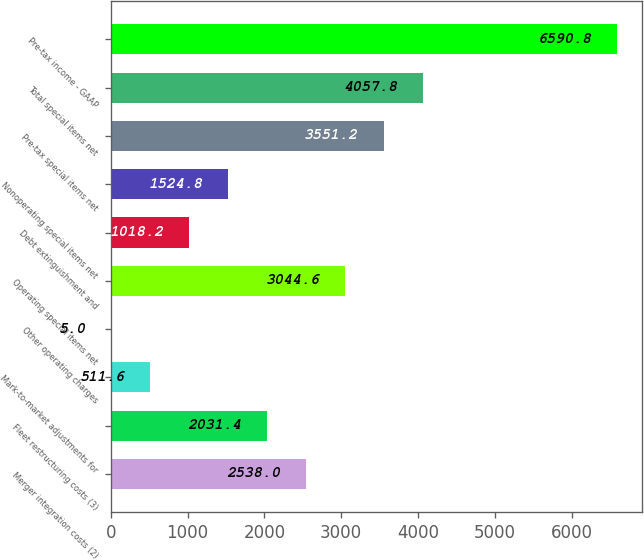Convert chart to OTSL. <chart><loc_0><loc_0><loc_500><loc_500><bar_chart><fcel>Merger integration costs (2)<fcel>Fleet restructuring costs (3)<fcel>Mark-to-market adjustments for<fcel>Other operating charges<fcel>Operating special items net<fcel>Debt extinguishment and<fcel>Nonoperating special items net<fcel>Pre-tax special items net<fcel>Total special items net<fcel>Pre-tax income - GAAP<nl><fcel>2538<fcel>2031.4<fcel>511.6<fcel>5<fcel>3044.6<fcel>1018.2<fcel>1524.8<fcel>3551.2<fcel>4057.8<fcel>6590.8<nl></chart> 